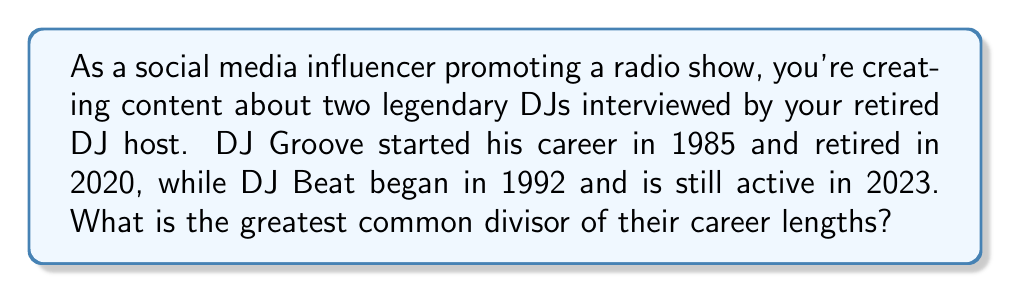Provide a solution to this math problem. Let's approach this step-by-step:

1) First, calculate the career lengths:
   DJ Groove: 2020 - 1985 = 35 years
   DJ Beat: 2023 - 1992 = 31 years

2) To find the greatest common divisor (GCD) of 35 and 31, we'll use the Euclidean algorithm:

   $$ GCD(a,b) = GCD(b, a \bmod b) $$

3) Apply the algorithm:
   $$ 35 = 1 \times 31 + 4 $$
   $$ 31 = 7 \times 4 + 3 $$
   $$ 4 = 1 \times 3 + 1 $$
   $$ 3 = 3 \times 1 + 0 $$

4) Working backwards, we see that 1 is the greatest common divisor.

This means that the greatest common factor in the career lengths of DJ Groove and DJ Beat is 1 year.
Answer: The greatest common divisor of the two DJs' career lengths is 1 year. 